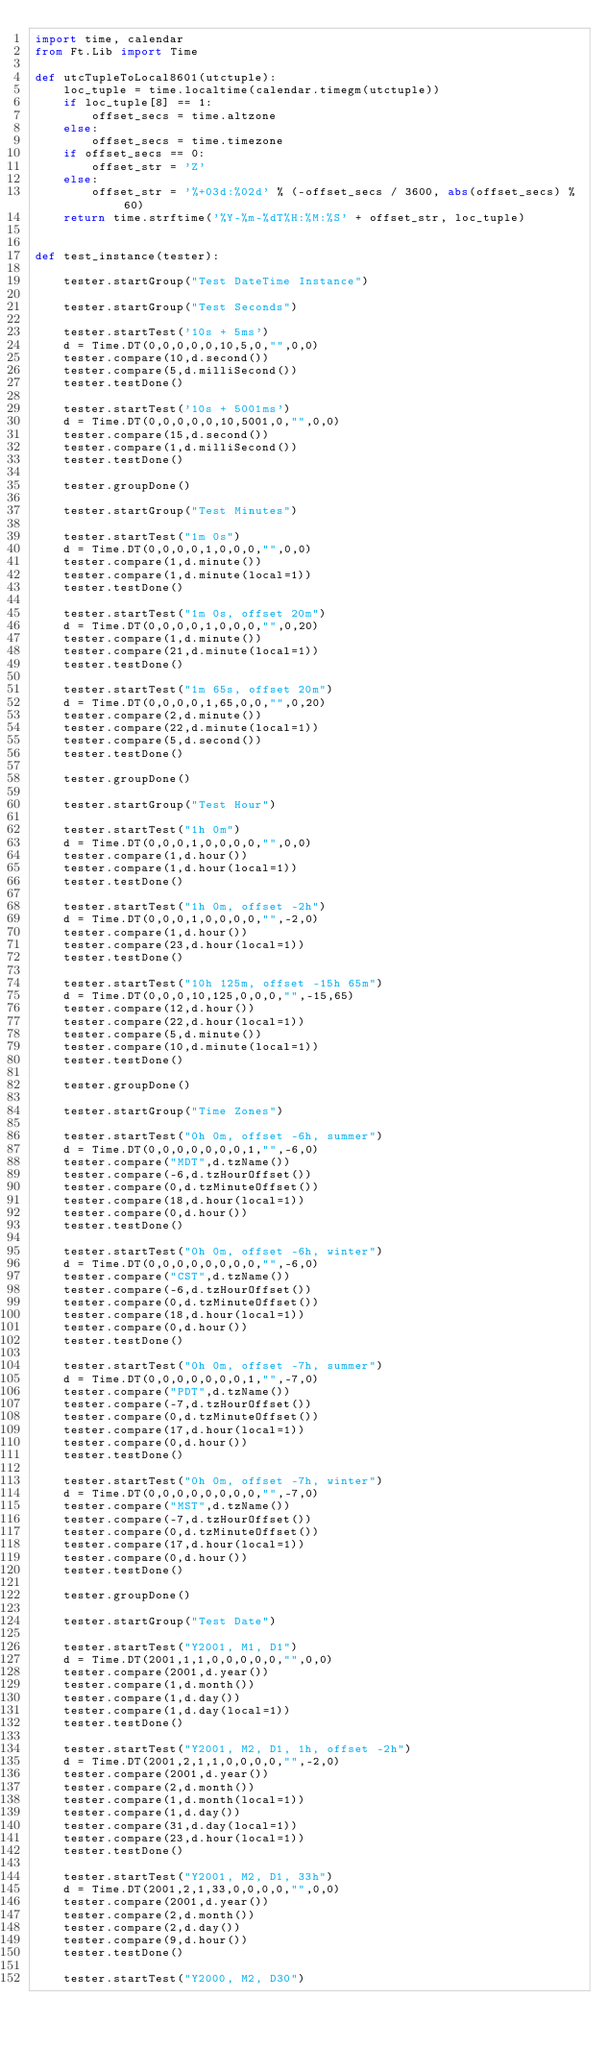<code> <loc_0><loc_0><loc_500><loc_500><_Python_>import time, calendar
from Ft.Lib import Time

def utcTupleToLocal8601(utctuple):
    loc_tuple = time.localtime(calendar.timegm(utctuple))
    if loc_tuple[8] == 1:
        offset_secs = time.altzone
    else:
        offset_secs = time.timezone
    if offset_secs == 0:
        offset_str = 'Z'
    else:
        offset_str = '%+03d:%02d' % (-offset_secs / 3600, abs(offset_secs) % 60)
    return time.strftime('%Y-%m-%dT%H:%M:%S' + offset_str, loc_tuple)


def test_instance(tester):

    tester.startGroup("Test DateTime Instance")

    tester.startGroup("Test Seconds")

    tester.startTest('10s + 5ms')
    d = Time.DT(0,0,0,0,0,10,5,0,"",0,0)
    tester.compare(10,d.second())
    tester.compare(5,d.milliSecond())
    tester.testDone()

    tester.startTest('10s + 5001ms')
    d = Time.DT(0,0,0,0,0,10,5001,0,"",0,0)
    tester.compare(15,d.second())
    tester.compare(1,d.milliSecond())
    tester.testDone()

    tester.groupDone()

    tester.startGroup("Test Minutes")

    tester.startTest("1m 0s")
    d = Time.DT(0,0,0,0,1,0,0,0,"",0,0)
    tester.compare(1,d.minute())
    tester.compare(1,d.minute(local=1))
    tester.testDone()

    tester.startTest("1m 0s, offset 20m")
    d = Time.DT(0,0,0,0,1,0,0,0,"",0,20)
    tester.compare(1,d.minute())
    tester.compare(21,d.minute(local=1))
    tester.testDone()

    tester.startTest("1m 65s, offset 20m")
    d = Time.DT(0,0,0,0,1,65,0,0,"",0,20)
    tester.compare(2,d.minute())
    tester.compare(22,d.minute(local=1))
    tester.compare(5,d.second())
    tester.testDone()

    tester.groupDone()

    tester.startGroup("Test Hour")

    tester.startTest("1h 0m")
    d = Time.DT(0,0,0,1,0,0,0,0,"",0,0)
    tester.compare(1,d.hour())
    tester.compare(1,d.hour(local=1))
    tester.testDone()

    tester.startTest("1h 0m, offset -2h")
    d = Time.DT(0,0,0,1,0,0,0,0,"",-2,0)
    tester.compare(1,d.hour())
    tester.compare(23,d.hour(local=1))
    tester.testDone()

    tester.startTest("10h 125m, offset -15h 65m")
    d = Time.DT(0,0,0,10,125,0,0,0,"",-15,65)
    tester.compare(12,d.hour())
    tester.compare(22,d.hour(local=1))
    tester.compare(5,d.minute())
    tester.compare(10,d.minute(local=1))
    tester.testDone()

    tester.groupDone()

    tester.startGroup("Time Zones")

    tester.startTest("0h 0m, offset -6h, summer")
    d = Time.DT(0,0,0,0,0,0,0,1,"",-6,0)
    tester.compare("MDT",d.tzName())
    tester.compare(-6,d.tzHourOffset())
    tester.compare(0,d.tzMinuteOffset())
    tester.compare(18,d.hour(local=1))
    tester.compare(0,d.hour())
    tester.testDone()

    tester.startTest("0h 0m, offset -6h, winter")
    d = Time.DT(0,0,0,0,0,0,0,0,"",-6,0)
    tester.compare("CST",d.tzName())
    tester.compare(-6,d.tzHourOffset())
    tester.compare(0,d.tzMinuteOffset())
    tester.compare(18,d.hour(local=1))
    tester.compare(0,d.hour())
    tester.testDone()

    tester.startTest("0h 0m, offset -7h, summer")
    d = Time.DT(0,0,0,0,0,0,0,1,"",-7,0)
    tester.compare("PDT",d.tzName())
    tester.compare(-7,d.tzHourOffset())
    tester.compare(0,d.tzMinuteOffset())
    tester.compare(17,d.hour(local=1))
    tester.compare(0,d.hour())
    tester.testDone()

    tester.startTest("0h 0m, offset -7h, winter")
    d = Time.DT(0,0,0,0,0,0,0,0,"",-7,0)
    tester.compare("MST",d.tzName())
    tester.compare(-7,d.tzHourOffset())
    tester.compare(0,d.tzMinuteOffset())
    tester.compare(17,d.hour(local=1))
    tester.compare(0,d.hour())
    tester.testDone()

    tester.groupDone()

    tester.startGroup("Test Date")

    tester.startTest("Y2001, M1, D1")
    d = Time.DT(2001,1,1,0,0,0,0,0,"",0,0)
    tester.compare(2001,d.year())
    tester.compare(1,d.month())
    tester.compare(1,d.day())
    tester.compare(1,d.day(local=1))
    tester.testDone()

    tester.startTest("Y2001, M2, D1, 1h, offset -2h")
    d = Time.DT(2001,2,1,1,0,0,0,0,"",-2,0)
    tester.compare(2001,d.year())
    tester.compare(2,d.month())
    tester.compare(1,d.month(local=1))
    tester.compare(1,d.day())
    tester.compare(31,d.day(local=1))
    tester.compare(23,d.hour(local=1))
    tester.testDone()

    tester.startTest("Y2001, M2, D1, 33h")
    d = Time.DT(2001,2,1,33,0,0,0,0,"",0,0)
    tester.compare(2001,d.year())
    tester.compare(2,d.month())
    tester.compare(2,d.day())
    tester.compare(9,d.hour())
    tester.testDone()

    tester.startTest("Y2000, M2, D30")</code> 